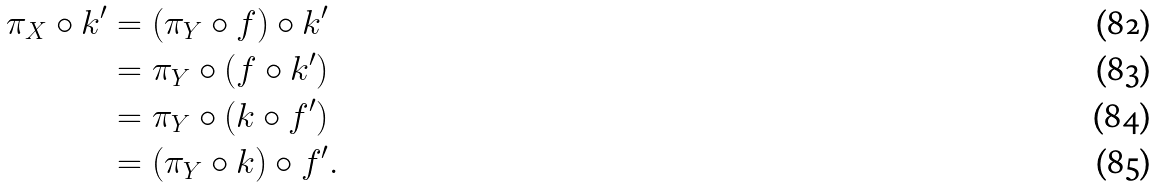<formula> <loc_0><loc_0><loc_500><loc_500>\pi _ { X } \circ k ^ { \prime } & = ( \pi _ { Y } \circ f ) \circ k ^ { \prime } \\ & = \pi _ { Y } \circ ( f \circ k ^ { \prime } ) \\ & = \pi _ { Y } \circ ( k \circ f ^ { \prime } ) \\ & = ( \pi _ { Y } \circ k ) \circ f ^ { \prime } .</formula> 